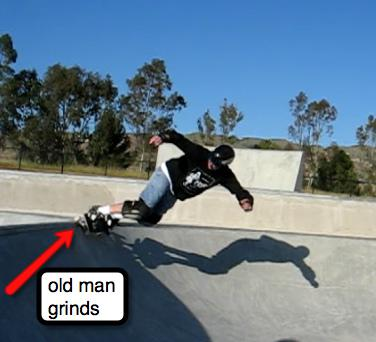Question: what is on the man's knees?
Choices:
A. Bruises.
B. Knee pads.
C. Cuts.
D. Scrapes.
Answer with the letter. Answer: B Question: where are the trees in relation to the fence?
Choices:
A. Behind.
B. Front.
C. Right side.
D. Below.
Answer with the letter. Answer: A Question: what color shirt is the man wearing?
Choices:
A. Teal.
B. Black.
C. Purple.
D. Neon.
Answer with the letter. Answer: B Question: what is the man doing?
Choices:
A. Talking.
B. Texting.
C. Sleeping.
D. Skateboarding.
Answer with the letter. Answer: D Question: what color are the tress?
Choices:
A. Teal.
B. Green.
C. Purple.
D. Neon.
Answer with the letter. Answer: B 